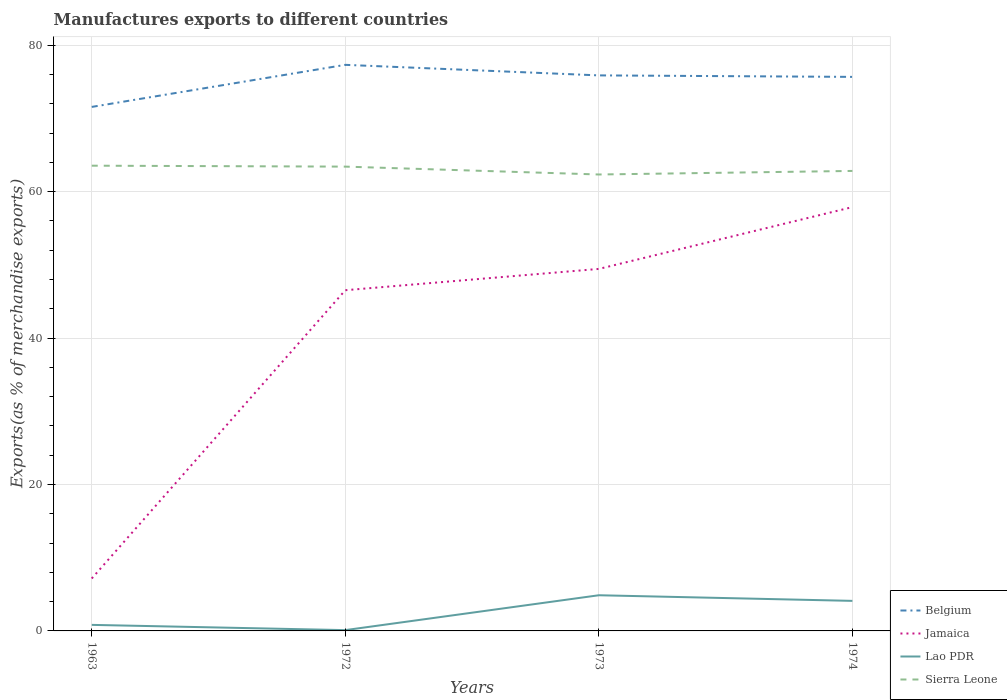Across all years, what is the maximum percentage of exports to different countries in Lao PDR?
Offer a terse response. 0.11. What is the total percentage of exports to different countries in Jamaica in the graph?
Offer a terse response. -39.37. What is the difference between the highest and the second highest percentage of exports to different countries in Jamaica?
Your answer should be compact. 50.72. What is the difference between the highest and the lowest percentage of exports to different countries in Jamaica?
Your answer should be compact. 3. Is the percentage of exports to different countries in Jamaica strictly greater than the percentage of exports to different countries in Sierra Leone over the years?
Make the answer very short. Yes. How many lines are there?
Provide a short and direct response. 4. How many years are there in the graph?
Give a very brief answer. 4. What is the difference between two consecutive major ticks on the Y-axis?
Keep it short and to the point. 20. Are the values on the major ticks of Y-axis written in scientific E-notation?
Your answer should be very brief. No. Does the graph contain grids?
Keep it short and to the point. Yes. Where does the legend appear in the graph?
Provide a succinct answer. Bottom right. What is the title of the graph?
Your response must be concise. Manufactures exports to different countries. What is the label or title of the X-axis?
Keep it short and to the point. Years. What is the label or title of the Y-axis?
Provide a succinct answer. Exports(as % of merchandise exports). What is the Exports(as % of merchandise exports) of Belgium in 1963?
Provide a succinct answer. 71.56. What is the Exports(as % of merchandise exports) of Jamaica in 1963?
Offer a very short reply. 7.16. What is the Exports(as % of merchandise exports) in Lao PDR in 1963?
Make the answer very short. 0.83. What is the Exports(as % of merchandise exports) in Sierra Leone in 1963?
Your response must be concise. 63.54. What is the Exports(as % of merchandise exports) in Belgium in 1972?
Provide a short and direct response. 77.31. What is the Exports(as % of merchandise exports) of Jamaica in 1972?
Your answer should be very brief. 46.53. What is the Exports(as % of merchandise exports) of Lao PDR in 1972?
Your answer should be very brief. 0.11. What is the Exports(as % of merchandise exports) in Sierra Leone in 1972?
Provide a succinct answer. 63.41. What is the Exports(as % of merchandise exports) in Belgium in 1973?
Provide a succinct answer. 75.87. What is the Exports(as % of merchandise exports) in Jamaica in 1973?
Your answer should be very brief. 49.44. What is the Exports(as % of merchandise exports) in Lao PDR in 1973?
Your answer should be compact. 4.87. What is the Exports(as % of merchandise exports) of Sierra Leone in 1973?
Provide a succinct answer. 62.33. What is the Exports(as % of merchandise exports) in Belgium in 1974?
Give a very brief answer. 75.66. What is the Exports(as % of merchandise exports) of Jamaica in 1974?
Provide a short and direct response. 57.88. What is the Exports(as % of merchandise exports) in Lao PDR in 1974?
Give a very brief answer. 4.1. What is the Exports(as % of merchandise exports) in Sierra Leone in 1974?
Ensure brevity in your answer.  62.82. Across all years, what is the maximum Exports(as % of merchandise exports) in Belgium?
Keep it short and to the point. 77.31. Across all years, what is the maximum Exports(as % of merchandise exports) in Jamaica?
Offer a very short reply. 57.88. Across all years, what is the maximum Exports(as % of merchandise exports) in Lao PDR?
Your answer should be compact. 4.87. Across all years, what is the maximum Exports(as % of merchandise exports) of Sierra Leone?
Offer a terse response. 63.54. Across all years, what is the minimum Exports(as % of merchandise exports) in Belgium?
Your answer should be very brief. 71.56. Across all years, what is the minimum Exports(as % of merchandise exports) in Jamaica?
Your answer should be very brief. 7.16. Across all years, what is the minimum Exports(as % of merchandise exports) of Lao PDR?
Your answer should be very brief. 0.11. Across all years, what is the minimum Exports(as % of merchandise exports) of Sierra Leone?
Ensure brevity in your answer.  62.33. What is the total Exports(as % of merchandise exports) of Belgium in the graph?
Offer a very short reply. 300.41. What is the total Exports(as % of merchandise exports) of Jamaica in the graph?
Your response must be concise. 161.01. What is the total Exports(as % of merchandise exports) of Lao PDR in the graph?
Give a very brief answer. 9.91. What is the total Exports(as % of merchandise exports) of Sierra Leone in the graph?
Keep it short and to the point. 252.1. What is the difference between the Exports(as % of merchandise exports) of Belgium in 1963 and that in 1972?
Keep it short and to the point. -5.75. What is the difference between the Exports(as % of merchandise exports) in Jamaica in 1963 and that in 1972?
Provide a succinct answer. -39.37. What is the difference between the Exports(as % of merchandise exports) of Lao PDR in 1963 and that in 1972?
Ensure brevity in your answer.  0.72. What is the difference between the Exports(as % of merchandise exports) in Sierra Leone in 1963 and that in 1972?
Your response must be concise. 0.13. What is the difference between the Exports(as % of merchandise exports) in Belgium in 1963 and that in 1973?
Your response must be concise. -4.3. What is the difference between the Exports(as % of merchandise exports) in Jamaica in 1963 and that in 1973?
Give a very brief answer. -42.28. What is the difference between the Exports(as % of merchandise exports) of Lao PDR in 1963 and that in 1973?
Offer a terse response. -4.05. What is the difference between the Exports(as % of merchandise exports) in Sierra Leone in 1963 and that in 1973?
Provide a succinct answer. 1.2. What is the difference between the Exports(as % of merchandise exports) of Belgium in 1963 and that in 1974?
Your response must be concise. -4.1. What is the difference between the Exports(as % of merchandise exports) in Jamaica in 1963 and that in 1974?
Offer a very short reply. -50.72. What is the difference between the Exports(as % of merchandise exports) in Lao PDR in 1963 and that in 1974?
Make the answer very short. -3.28. What is the difference between the Exports(as % of merchandise exports) of Sierra Leone in 1963 and that in 1974?
Your answer should be very brief. 0.72. What is the difference between the Exports(as % of merchandise exports) of Belgium in 1972 and that in 1973?
Your answer should be very brief. 1.44. What is the difference between the Exports(as % of merchandise exports) of Jamaica in 1972 and that in 1973?
Provide a short and direct response. -2.91. What is the difference between the Exports(as % of merchandise exports) in Lao PDR in 1972 and that in 1973?
Offer a very short reply. -4.76. What is the difference between the Exports(as % of merchandise exports) of Sierra Leone in 1972 and that in 1973?
Keep it short and to the point. 1.07. What is the difference between the Exports(as % of merchandise exports) in Belgium in 1972 and that in 1974?
Give a very brief answer. 1.65. What is the difference between the Exports(as % of merchandise exports) in Jamaica in 1972 and that in 1974?
Your answer should be compact. -11.35. What is the difference between the Exports(as % of merchandise exports) in Lao PDR in 1972 and that in 1974?
Offer a terse response. -3.99. What is the difference between the Exports(as % of merchandise exports) of Sierra Leone in 1972 and that in 1974?
Offer a very short reply. 0.59. What is the difference between the Exports(as % of merchandise exports) in Belgium in 1973 and that in 1974?
Your response must be concise. 0.2. What is the difference between the Exports(as % of merchandise exports) of Jamaica in 1973 and that in 1974?
Keep it short and to the point. -8.44. What is the difference between the Exports(as % of merchandise exports) in Lao PDR in 1973 and that in 1974?
Ensure brevity in your answer.  0.77. What is the difference between the Exports(as % of merchandise exports) in Sierra Leone in 1973 and that in 1974?
Provide a succinct answer. -0.49. What is the difference between the Exports(as % of merchandise exports) of Belgium in 1963 and the Exports(as % of merchandise exports) of Jamaica in 1972?
Offer a terse response. 25.03. What is the difference between the Exports(as % of merchandise exports) of Belgium in 1963 and the Exports(as % of merchandise exports) of Lao PDR in 1972?
Your answer should be very brief. 71.45. What is the difference between the Exports(as % of merchandise exports) in Belgium in 1963 and the Exports(as % of merchandise exports) in Sierra Leone in 1972?
Your response must be concise. 8.15. What is the difference between the Exports(as % of merchandise exports) in Jamaica in 1963 and the Exports(as % of merchandise exports) in Lao PDR in 1972?
Make the answer very short. 7.05. What is the difference between the Exports(as % of merchandise exports) in Jamaica in 1963 and the Exports(as % of merchandise exports) in Sierra Leone in 1972?
Provide a short and direct response. -56.25. What is the difference between the Exports(as % of merchandise exports) in Lao PDR in 1963 and the Exports(as % of merchandise exports) in Sierra Leone in 1972?
Offer a very short reply. -62.58. What is the difference between the Exports(as % of merchandise exports) of Belgium in 1963 and the Exports(as % of merchandise exports) of Jamaica in 1973?
Your answer should be compact. 22.12. What is the difference between the Exports(as % of merchandise exports) of Belgium in 1963 and the Exports(as % of merchandise exports) of Lao PDR in 1973?
Your response must be concise. 66.69. What is the difference between the Exports(as % of merchandise exports) of Belgium in 1963 and the Exports(as % of merchandise exports) of Sierra Leone in 1973?
Offer a very short reply. 9.23. What is the difference between the Exports(as % of merchandise exports) in Jamaica in 1963 and the Exports(as % of merchandise exports) in Lao PDR in 1973?
Keep it short and to the point. 2.29. What is the difference between the Exports(as % of merchandise exports) in Jamaica in 1963 and the Exports(as % of merchandise exports) in Sierra Leone in 1973?
Make the answer very short. -55.17. What is the difference between the Exports(as % of merchandise exports) in Lao PDR in 1963 and the Exports(as % of merchandise exports) in Sierra Leone in 1973?
Offer a terse response. -61.51. What is the difference between the Exports(as % of merchandise exports) of Belgium in 1963 and the Exports(as % of merchandise exports) of Jamaica in 1974?
Ensure brevity in your answer.  13.68. What is the difference between the Exports(as % of merchandise exports) of Belgium in 1963 and the Exports(as % of merchandise exports) of Lao PDR in 1974?
Provide a succinct answer. 67.46. What is the difference between the Exports(as % of merchandise exports) in Belgium in 1963 and the Exports(as % of merchandise exports) in Sierra Leone in 1974?
Ensure brevity in your answer.  8.74. What is the difference between the Exports(as % of merchandise exports) in Jamaica in 1963 and the Exports(as % of merchandise exports) in Lao PDR in 1974?
Provide a succinct answer. 3.06. What is the difference between the Exports(as % of merchandise exports) of Jamaica in 1963 and the Exports(as % of merchandise exports) of Sierra Leone in 1974?
Provide a short and direct response. -55.66. What is the difference between the Exports(as % of merchandise exports) of Lao PDR in 1963 and the Exports(as % of merchandise exports) of Sierra Leone in 1974?
Give a very brief answer. -62. What is the difference between the Exports(as % of merchandise exports) in Belgium in 1972 and the Exports(as % of merchandise exports) in Jamaica in 1973?
Offer a very short reply. 27.87. What is the difference between the Exports(as % of merchandise exports) of Belgium in 1972 and the Exports(as % of merchandise exports) of Lao PDR in 1973?
Your answer should be compact. 72.44. What is the difference between the Exports(as % of merchandise exports) of Belgium in 1972 and the Exports(as % of merchandise exports) of Sierra Leone in 1973?
Keep it short and to the point. 14.97. What is the difference between the Exports(as % of merchandise exports) in Jamaica in 1972 and the Exports(as % of merchandise exports) in Lao PDR in 1973?
Ensure brevity in your answer.  41.66. What is the difference between the Exports(as % of merchandise exports) in Jamaica in 1972 and the Exports(as % of merchandise exports) in Sierra Leone in 1973?
Your response must be concise. -15.8. What is the difference between the Exports(as % of merchandise exports) of Lao PDR in 1972 and the Exports(as % of merchandise exports) of Sierra Leone in 1973?
Ensure brevity in your answer.  -62.23. What is the difference between the Exports(as % of merchandise exports) in Belgium in 1972 and the Exports(as % of merchandise exports) in Jamaica in 1974?
Offer a terse response. 19.43. What is the difference between the Exports(as % of merchandise exports) of Belgium in 1972 and the Exports(as % of merchandise exports) of Lao PDR in 1974?
Your answer should be very brief. 73.21. What is the difference between the Exports(as % of merchandise exports) in Belgium in 1972 and the Exports(as % of merchandise exports) in Sierra Leone in 1974?
Provide a short and direct response. 14.49. What is the difference between the Exports(as % of merchandise exports) of Jamaica in 1972 and the Exports(as % of merchandise exports) of Lao PDR in 1974?
Your answer should be compact. 42.43. What is the difference between the Exports(as % of merchandise exports) of Jamaica in 1972 and the Exports(as % of merchandise exports) of Sierra Leone in 1974?
Your response must be concise. -16.29. What is the difference between the Exports(as % of merchandise exports) in Lao PDR in 1972 and the Exports(as % of merchandise exports) in Sierra Leone in 1974?
Your answer should be compact. -62.71. What is the difference between the Exports(as % of merchandise exports) of Belgium in 1973 and the Exports(as % of merchandise exports) of Jamaica in 1974?
Offer a very short reply. 17.99. What is the difference between the Exports(as % of merchandise exports) in Belgium in 1973 and the Exports(as % of merchandise exports) in Lao PDR in 1974?
Ensure brevity in your answer.  71.76. What is the difference between the Exports(as % of merchandise exports) in Belgium in 1973 and the Exports(as % of merchandise exports) in Sierra Leone in 1974?
Provide a short and direct response. 13.05. What is the difference between the Exports(as % of merchandise exports) of Jamaica in 1973 and the Exports(as % of merchandise exports) of Lao PDR in 1974?
Make the answer very short. 45.34. What is the difference between the Exports(as % of merchandise exports) of Jamaica in 1973 and the Exports(as % of merchandise exports) of Sierra Leone in 1974?
Provide a succinct answer. -13.38. What is the difference between the Exports(as % of merchandise exports) in Lao PDR in 1973 and the Exports(as % of merchandise exports) in Sierra Leone in 1974?
Make the answer very short. -57.95. What is the average Exports(as % of merchandise exports) of Belgium per year?
Provide a short and direct response. 75.1. What is the average Exports(as % of merchandise exports) in Jamaica per year?
Your response must be concise. 40.25. What is the average Exports(as % of merchandise exports) of Lao PDR per year?
Your answer should be compact. 2.48. What is the average Exports(as % of merchandise exports) in Sierra Leone per year?
Give a very brief answer. 63.03. In the year 1963, what is the difference between the Exports(as % of merchandise exports) of Belgium and Exports(as % of merchandise exports) of Jamaica?
Provide a succinct answer. 64.4. In the year 1963, what is the difference between the Exports(as % of merchandise exports) in Belgium and Exports(as % of merchandise exports) in Lao PDR?
Offer a terse response. 70.74. In the year 1963, what is the difference between the Exports(as % of merchandise exports) of Belgium and Exports(as % of merchandise exports) of Sierra Leone?
Your answer should be very brief. 8.03. In the year 1963, what is the difference between the Exports(as % of merchandise exports) of Jamaica and Exports(as % of merchandise exports) of Lao PDR?
Your response must be concise. 6.33. In the year 1963, what is the difference between the Exports(as % of merchandise exports) of Jamaica and Exports(as % of merchandise exports) of Sierra Leone?
Provide a short and direct response. -56.38. In the year 1963, what is the difference between the Exports(as % of merchandise exports) in Lao PDR and Exports(as % of merchandise exports) in Sierra Leone?
Your answer should be compact. -62.71. In the year 1972, what is the difference between the Exports(as % of merchandise exports) of Belgium and Exports(as % of merchandise exports) of Jamaica?
Give a very brief answer. 30.78. In the year 1972, what is the difference between the Exports(as % of merchandise exports) in Belgium and Exports(as % of merchandise exports) in Lao PDR?
Give a very brief answer. 77.2. In the year 1972, what is the difference between the Exports(as % of merchandise exports) of Belgium and Exports(as % of merchandise exports) of Sierra Leone?
Provide a succinct answer. 13.9. In the year 1972, what is the difference between the Exports(as % of merchandise exports) in Jamaica and Exports(as % of merchandise exports) in Lao PDR?
Keep it short and to the point. 46.42. In the year 1972, what is the difference between the Exports(as % of merchandise exports) of Jamaica and Exports(as % of merchandise exports) of Sierra Leone?
Make the answer very short. -16.88. In the year 1972, what is the difference between the Exports(as % of merchandise exports) in Lao PDR and Exports(as % of merchandise exports) in Sierra Leone?
Provide a short and direct response. -63.3. In the year 1973, what is the difference between the Exports(as % of merchandise exports) of Belgium and Exports(as % of merchandise exports) of Jamaica?
Your answer should be compact. 26.43. In the year 1973, what is the difference between the Exports(as % of merchandise exports) of Belgium and Exports(as % of merchandise exports) of Lao PDR?
Your answer should be very brief. 71. In the year 1973, what is the difference between the Exports(as % of merchandise exports) of Belgium and Exports(as % of merchandise exports) of Sierra Leone?
Your answer should be compact. 13.53. In the year 1973, what is the difference between the Exports(as % of merchandise exports) of Jamaica and Exports(as % of merchandise exports) of Lao PDR?
Offer a very short reply. 44.57. In the year 1973, what is the difference between the Exports(as % of merchandise exports) of Jamaica and Exports(as % of merchandise exports) of Sierra Leone?
Provide a succinct answer. -12.9. In the year 1973, what is the difference between the Exports(as % of merchandise exports) of Lao PDR and Exports(as % of merchandise exports) of Sierra Leone?
Provide a short and direct response. -57.46. In the year 1974, what is the difference between the Exports(as % of merchandise exports) in Belgium and Exports(as % of merchandise exports) in Jamaica?
Offer a very short reply. 17.78. In the year 1974, what is the difference between the Exports(as % of merchandise exports) of Belgium and Exports(as % of merchandise exports) of Lao PDR?
Your answer should be compact. 71.56. In the year 1974, what is the difference between the Exports(as % of merchandise exports) in Belgium and Exports(as % of merchandise exports) in Sierra Leone?
Make the answer very short. 12.84. In the year 1974, what is the difference between the Exports(as % of merchandise exports) of Jamaica and Exports(as % of merchandise exports) of Lao PDR?
Provide a succinct answer. 53.78. In the year 1974, what is the difference between the Exports(as % of merchandise exports) in Jamaica and Exports(as % of merchandise exports) in Sierra Leone?
Make the answer very short. -4.94. In the year 1974, what is the difference between the Exports(as % of merchandise exports) in Lao PDR and Exports(as % of merchandise exports) in Sierra Leone?
Keep it short and to the point. -58.72. What is the ratio of the Exports(as % of merchandise exports) of Belgium in 1963 to that in 1972?
Your response must be concise. 0.93. What is the ratio of the Exports(as % of merchandise exports) of Jamaica in 1963 to that in 1972?
Offer a terse response. 0.15. What is the ratio of the Exports(as % of merchandise exports) in Lao PDR in 1963 to that in 1972?
Provide a succinct answer. 7.58. What is the ratio of the Exports(as % of merchandise exports) in Sierra Leone in 1963 to that in 1972?
Keep it short and to the point. 1. What is the ratio of the Exports(as % of merchandise exports) of Belgium in 1963 to that in 1973?
Make the answer very short. 0.94. What is the ratio of the Exports(as % of merchandise exports) in Jamaica in 1963 to that in 1973?
Make the answer very short. 0.14. What is the ratio of the Exports(as % of merchandise exports) in Lao PDR in 1963 to that in 1973?
Offer a terse response. 0.17. What is the ratio of the Exports(as % of merchandise exports) in Sierra Leone in 1963 to that in 1973?
Your answer should be compact. 1.02. What is the ratio of the Exports(as % of merchandise exports) of Belgium in 1963 to that in 1974?
Your answer should be compact. 0.95. What is the ratio of the Exports(as % of merchandise exports) of Jamaica in 1963 to that in 1974?
Provide a succinct answer. 0.12. What is the ratio of the Exports(as % of merchandise exports) of Lao PDR in 1963 to that in 1974?
Your answer should be compact. 0.2. What is the ratio of the Exports(as % of merchandise exports) of Sierra Leone in 1963 to that in 1974?
Offer a terse response. 1.01. What is the ratio of the Exports(as % of merchandise exports) of Jamaica in 1972 to that in 1973?
Make the answer very short. 0.94. What is the ratio of the Exports(as % of merchandise exports) of Lao PDR in 1972 to that in 1973?
Provide a succinct answer. 0.02. What is the ratio of the Exports(as % of merchandise exports) of Sierra Leone in 1972 to that in 1973?
Your answer should be very brief. 1.02. What is the ratio of the Exports(as % of merchandise exports) of Belgium in 1972 to that in 1974?
Make the answer very short. 1.02. What is the ratio of the Exports(as % of merchandise exports) of Jamaica in 1972 to that in 1974?
Keep it short and to the point. 0.8. What is the ratio of the Exports(as % of merchandise exports) of Lao PDR in 1972 to that in 1974?
Provide a succinct answer. 0.03. What is the ratio of the Exports(as % of merchandise exports) of Sierra Leone in 1972 to that in 1974?
Offer a very short reply. 1.01. What is the ratio of the Exports(as % of merchandise exports) of Belgium in 1973 to that in 1974?
Make the answer very short. 1. What is the ratio of the Exports(as % of merchandise exports) in Jamaica in 1973 to that in 1974?
Keep it short and to the point. 0.85. What is the ratio of the Exports(as % of merchandise exports) of Lao PDR in 1973 to that in 1974?
Your response must be concise. 1.19. What is the difference between the highest and the second highest Exports(as % of merchandise exports) of Belgium?
Offer a very short reply. 1.44. What is the difference between the highest and the second highest Exports(as % of merchandise exports) in Jamaica?
Ensure brevity in your answer.  8.44. What is the difference between the highest and the second highest Exports(as % of merchandise exports) of Lao PDR?
Your answer should be compact. 0.77. What is the difference between the highest and the second highest Exports(as % of merchandise exports) of Sierra Leone?
Your answer should be very brief. 0.13. What is the difference between the highest and the lowest Exports(as % of merchandise exports) in Belgium?
Make the answer very short. 5.75. What is the difference between the highest and the lowest Exports(as % of merchandise exports) of Jamaica?
Your response must be concise. 50.72. What is the difference between the highest and the lowest Exports(as % of merchandise exports) of Lao PDR?
Provide a succinct answer. 4.76. What is the difference between the highest and the lowest Exports(as % of merchandise exports) in Sierra Leone?
Provide a succinct answer. 1.2. 